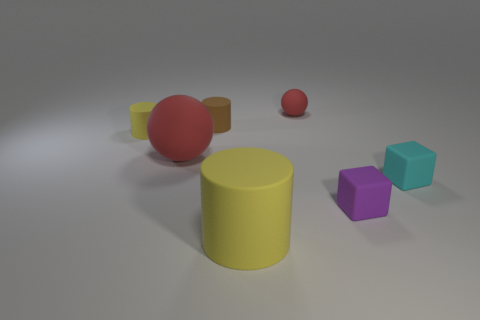Add 2 tiny cyan metallic balls. How many objects exist? 9 Subtract all balls. How many objects are left? 5 Add 6 red rubber objects. How many red rubber objects exist? 8 Subtract 2 yellow cylinders. How many objects are left? 5 Subtract all gray cylinders. Subtract all brown rubber things. How many objects are left? 6 Add 3 matte blocks. How many matte blocks are left? 5 